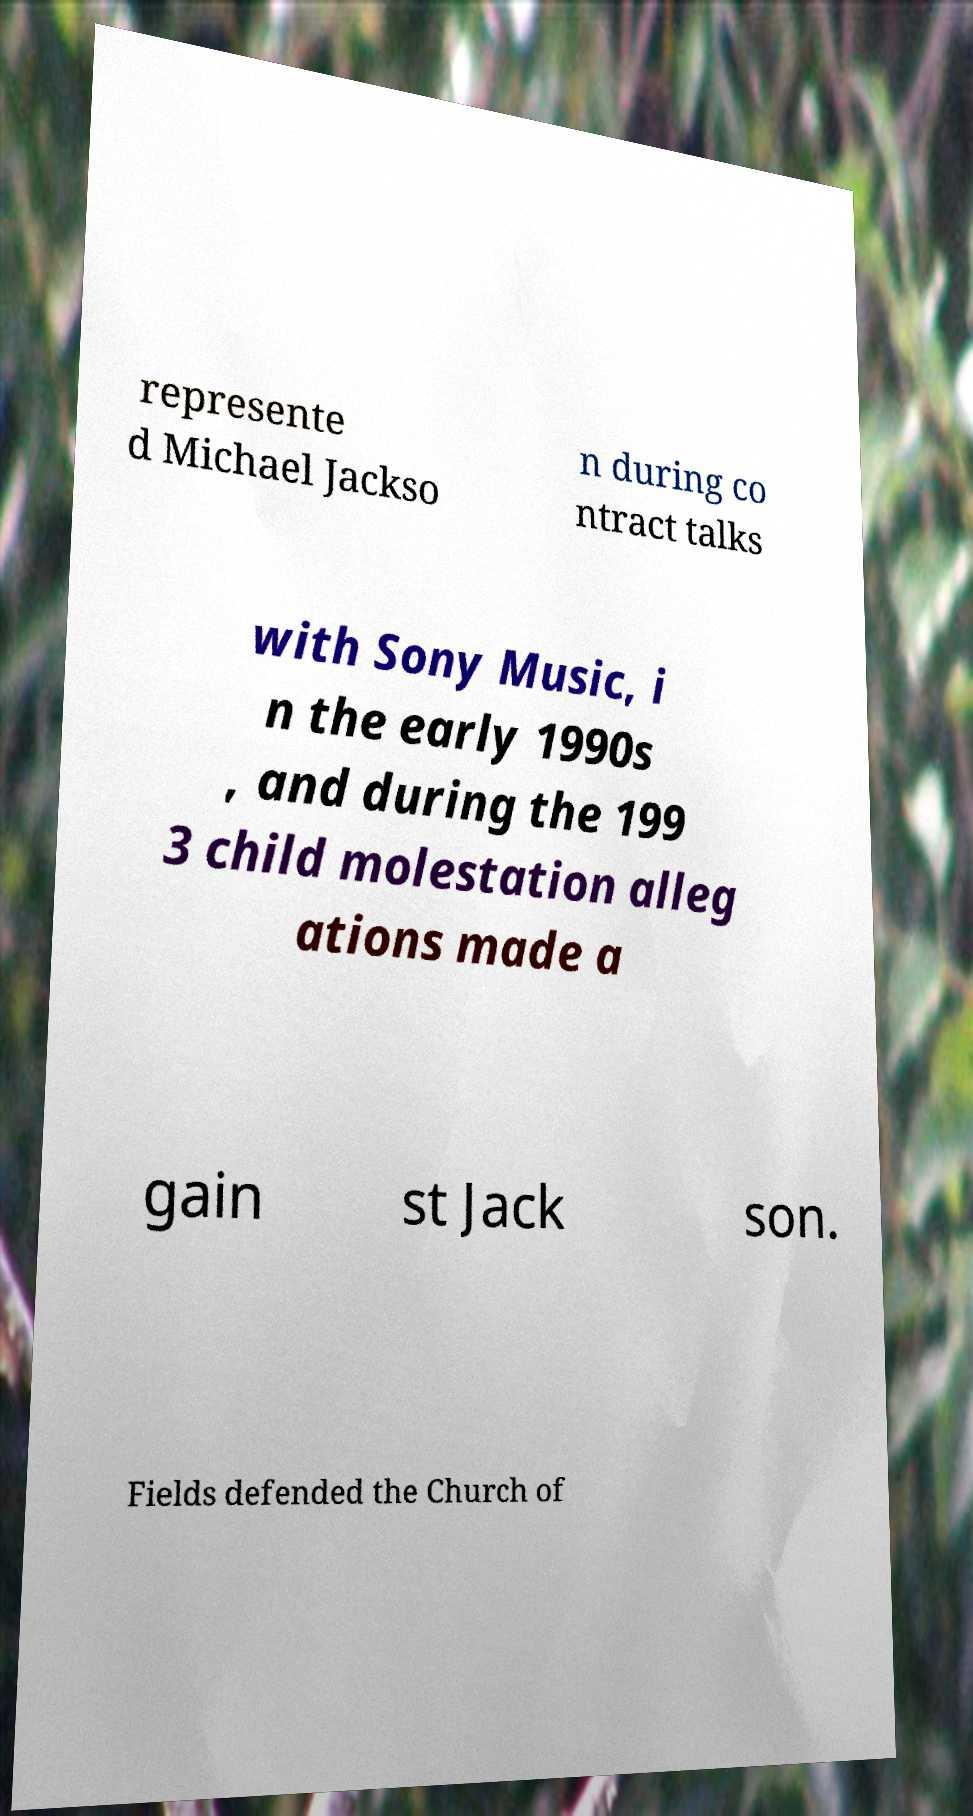Can you accurately transcribe the text from the provided image for me? represente d Michael Jackso n during co ntract talks with Sony Music, i n the early 1990s , and during the 199 3 child molestation alleg ations made a gain st Jack son. Fields defended the Church of 